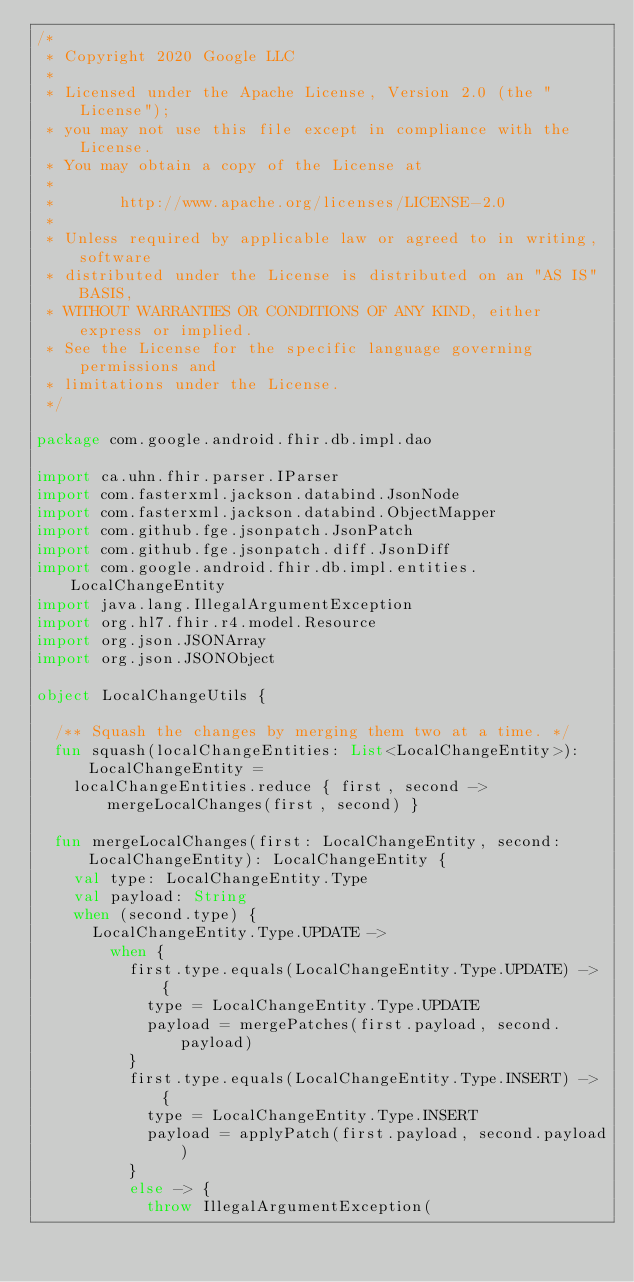<code> <loc_0><loc_0><loc_500><loc_500><_Kotlin_>/*
 * Copyright 2020 Google LLC
 *
 * Licensed under the Apache License, Version 2.0 (the "License");
 * you may not use this file except in compliance with the License.
 * You may obtain a copy of the License at
 *
 *       http://www.apache.org/licenses/LICENSE-2.0
 *
 * Unless required by applicable law or agreed to in writing, software
 * distributed under the License is distributed on an "AS IS" BASIS,
 * WITHOUT WARRANTIES OR CONDITIONS OF ANY KIND, either express or implied.
 * See the License for the specific language governing permissions and
 * limitations under the License.
 */

package com.google.android.fhir.db.impl.dao

import ca.uhn.fhir.parser.IParser
import com.fasterxml.jackson.databind.JsonNode
import com.fasterxml.jackson.databind.ObjectMapper
import com.github.fge.jsonpatch.JsonPatch
import com.github.fge.jsonpatch.diff.JsonDiff
import com.google.android.fhir.db.impl.entities.LocalChangeEntity
import java.lang.IllegalArgumentException
import org.hl7.fhir.r4.model.Resource
import org.json.JSONArray
import org.json.JSONObject

object LocalChangeUtils {

  /** Squash the changes by merging them two at a time. */
  fun squash(localChangeEntities: List<LocalChangeEntity>): LocalChangeEntity =
    localChangeEntities.reduce { first, second -> mergeLocalChanges(first, second) }

  fun mergeLocalChanges(first: LocalChangeEntity, second: LocalChangeEntity): LocalChangeEntity {
    val type: LocalChangeEntity.Type
    val payload: String
    when (second.type) {
      LocalChangeEntity.Type.UPDATE ->
        when {
          first.type.equals(LocalChangeEntity.Type.UPDATE) -> {
            type = LocalChangeEntity.Type.UPDATE
            payload = mergePatches(first.payload, second.payload)
          }
          first.type.equals(LocalChangeEntity.Type.INSERT) -> {
            type = LocalChangeEntity.Type.INSERT
            payload = applyPatch(first.payload, second.payload)
          }
          else -> {
            throw IllegalArgumentException(</code> 